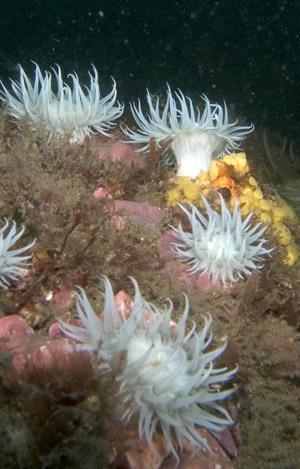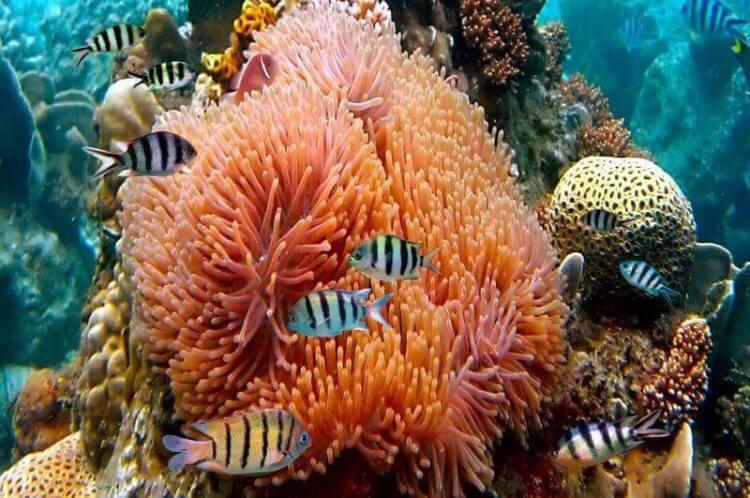The first image is the image on the left, the second image is the image on the right. Considering the images on both sides, is "Left image shows at least five of the same type of anemones with pale tendrils." valid? Answer yes or no. Yes. 